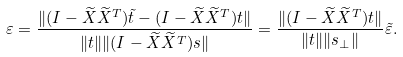<formula> <loc_0><loc_0><loc_500><loc_500>\varepsilon = \frac { \| ( I - \widetilde { X } \widetilde { X } ^ { T } ) \tilde { t } - ( I - \widetilde { X } \widetilde { X } ^ { T } ) t \| } { \| t \| \| ( I - \widetilde { X } \widetilde { X } ^ { T } ) s \| } = \frac { \| ( I - \widetilde { X } \widetilde { X } ^ { T } ) t \| } { \| t \| \| s _ { \perp } \| } \tilde { \varepsilon } .</formula> 